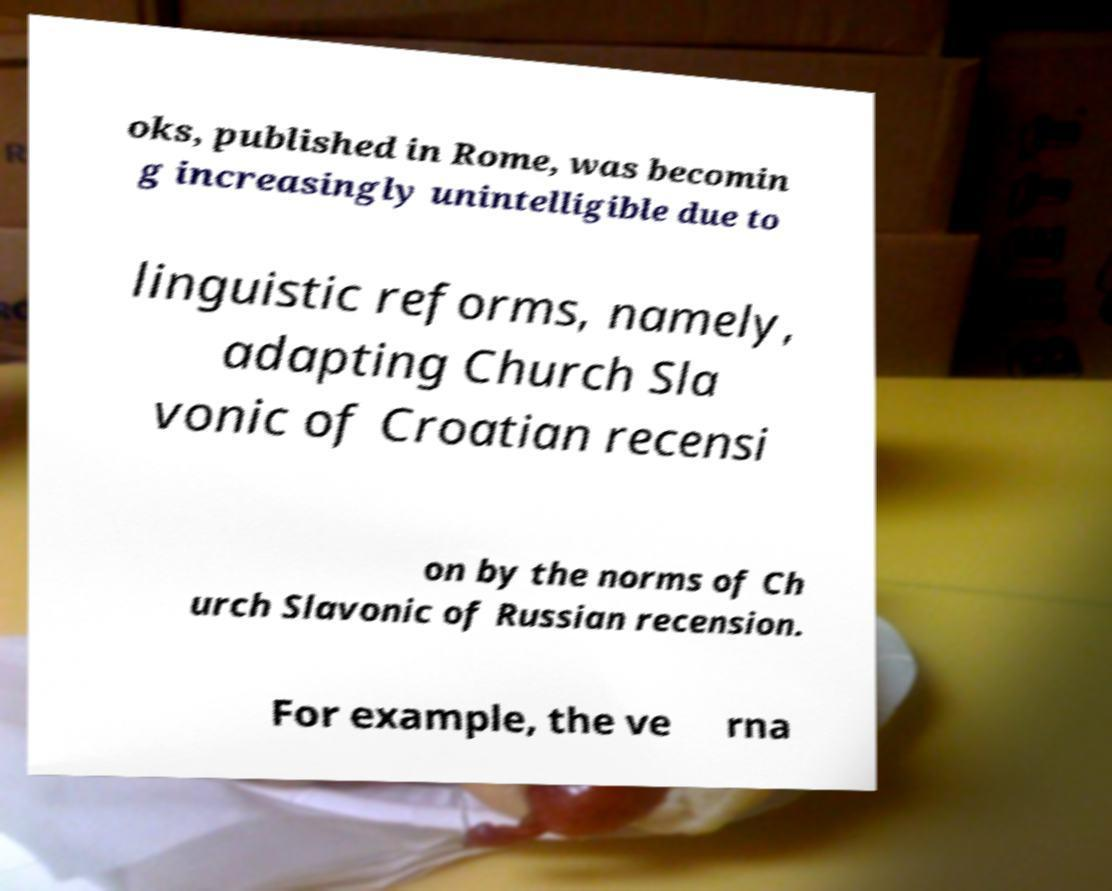Can you accurately transcribe the text from the provided image for me? oks, published in Rome, was becomin g increasingly unintelligible due to linguistic reforms, namely, adapting Church Sla vonic of Croatian recensi on by the norms of Ch urch Slavonic of Russian recension. For example, the ve rna 